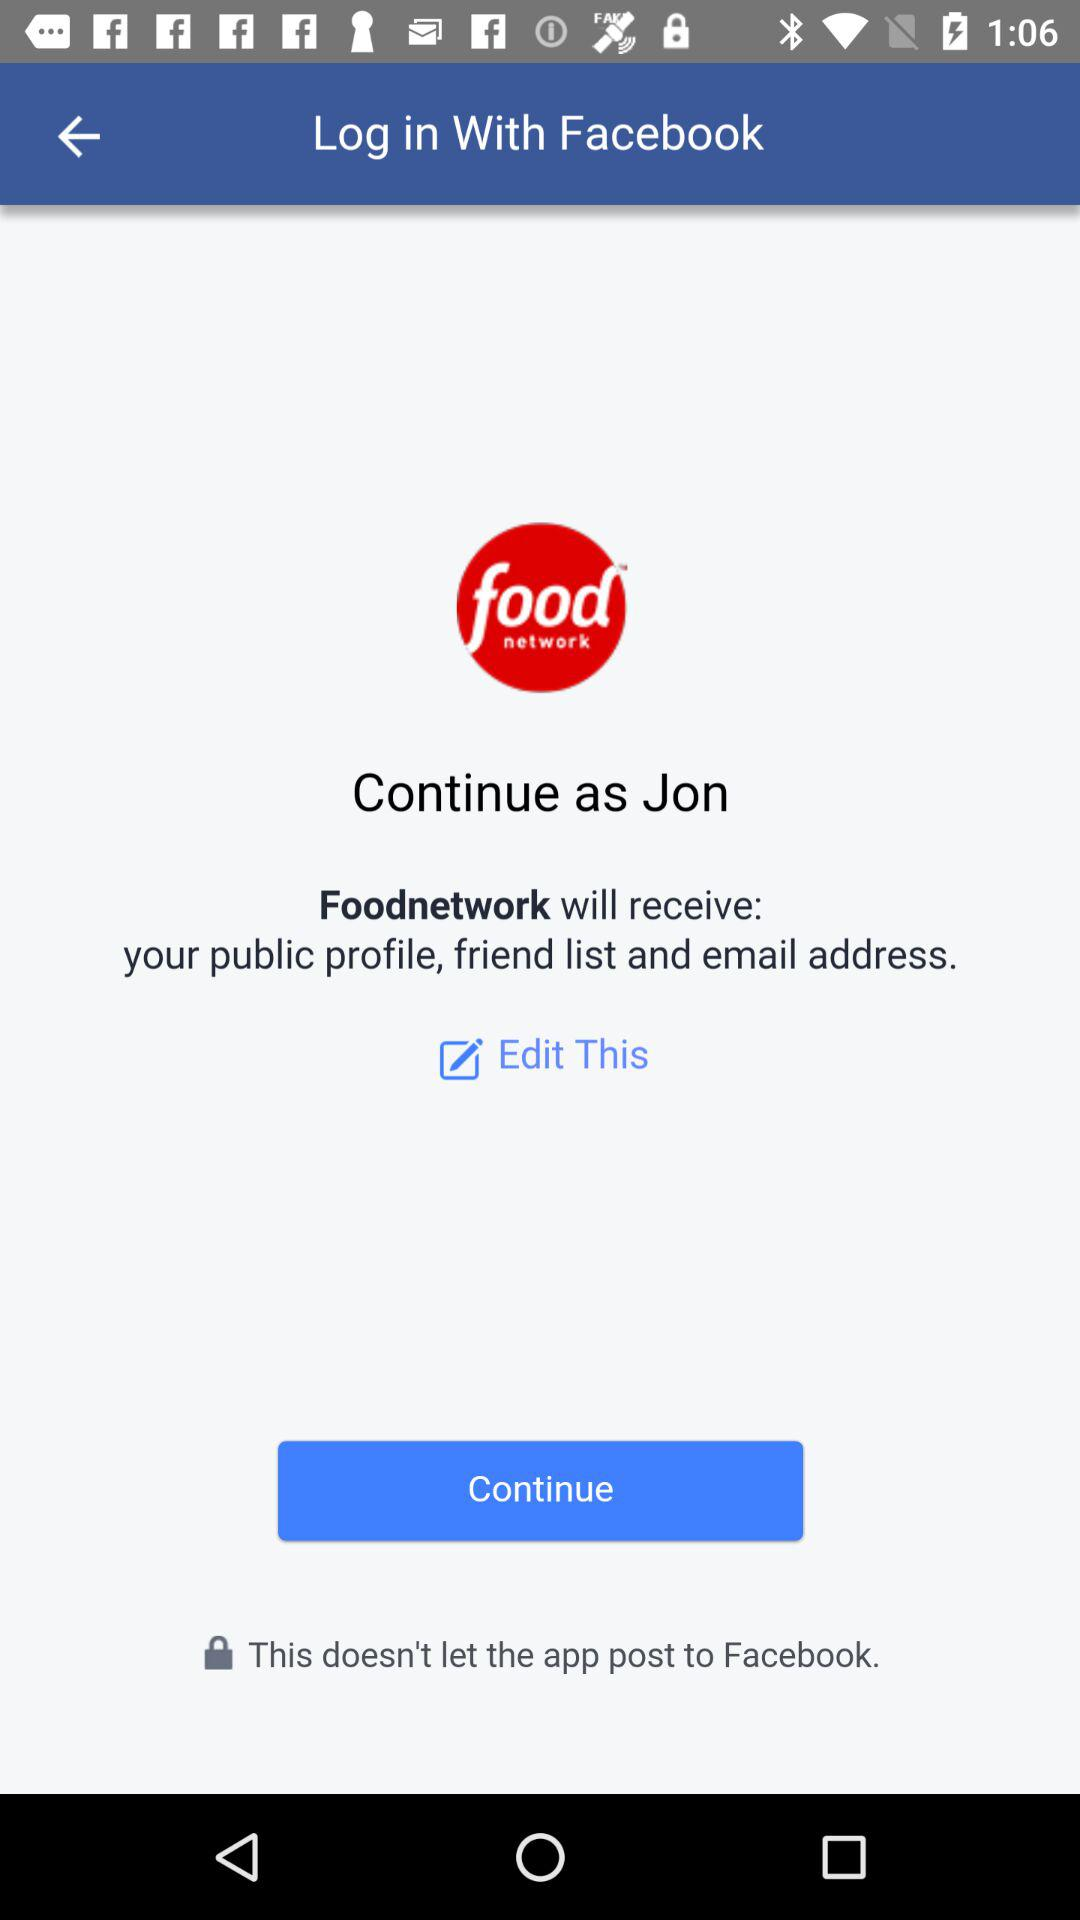Who will receive the public profile? The public profile will be received by "Foodnetwork". 